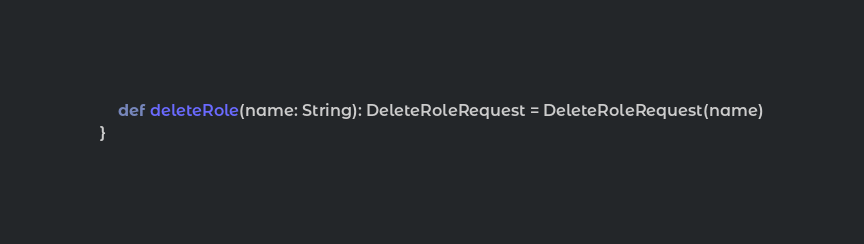<code> <loc_0><loc_0><loc_500><loc_500><_Scala_>	def deleteRole(name: String): DeleteRoleRequest = DeleteRoleRequest(name)
}</code> 